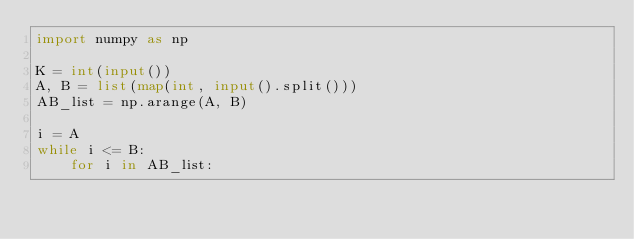<code> <loc_0><loc_0><loc_500><loc_500><_Python_>import numpy as np

K = int(input())
A, B = list(map(int, input().split()))
AB_list = np.arange(A, B)

i = A
while i <= B:
    for i in AB_list:</code> 